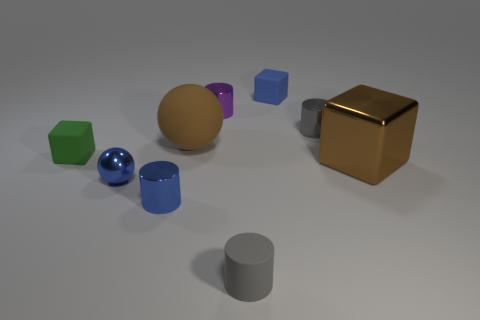Subtract 2 cylinders. How many cylinders are left? 2 Subtract all yellow cylinders. Subtract all purple spheres. How many cylinders are left? 4 Subtract all tiny blocks. How many blocks are left? 1 Subtract all cylinders. How many objects are left? 5 Subtract all red things. Subtract all tiny purple metallic cylinders. How many objects are left? 8 Add 7 tiny blue cylinders. How many tiny blue cylinders are left? 8 Add 2 green rubber objects. How many green rubber objects exist? 3 Subtract 0 red cylinders. How many objects are left? 9 